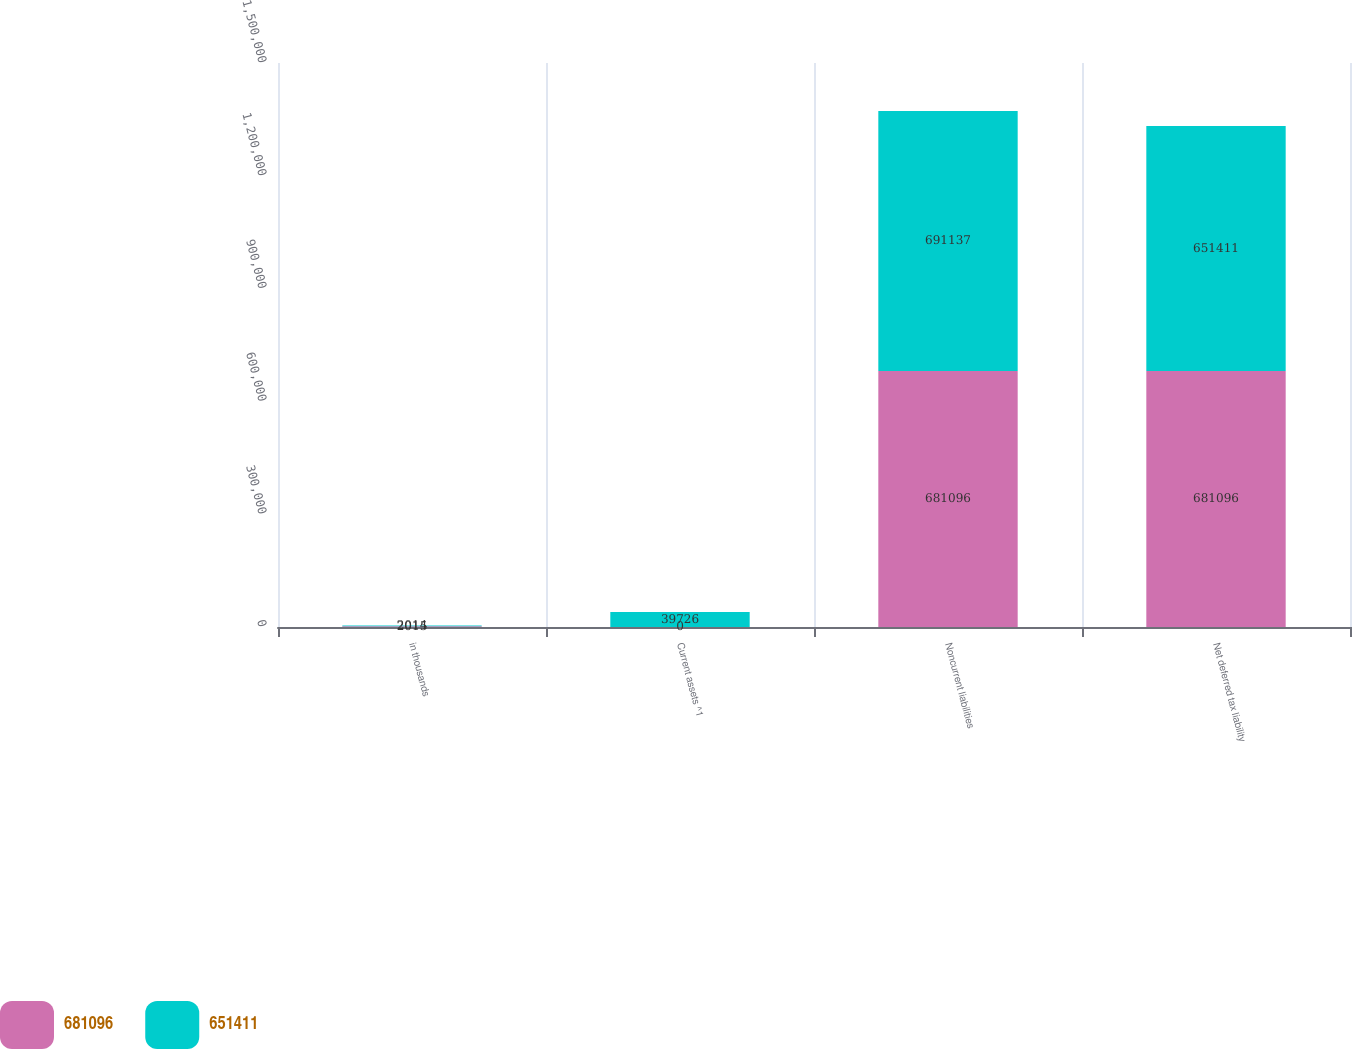Convert chart to OTSL. <chart><loc_0><loc_0><loc_500><loc_500><stacked_bar_chart><ecel><fcel>in thousands<fcel>Current assets ^1<fcel>Noncurrent liabilities<fcel>Net deferred tax liability<nl><fcel>681096<fcel>2015<fcel>0<fcel>681096<fcel>681096<nl><fcel>651411<fcel>2014<fcel>39726<fcel>691137<fcel>651411<nl></chart> 